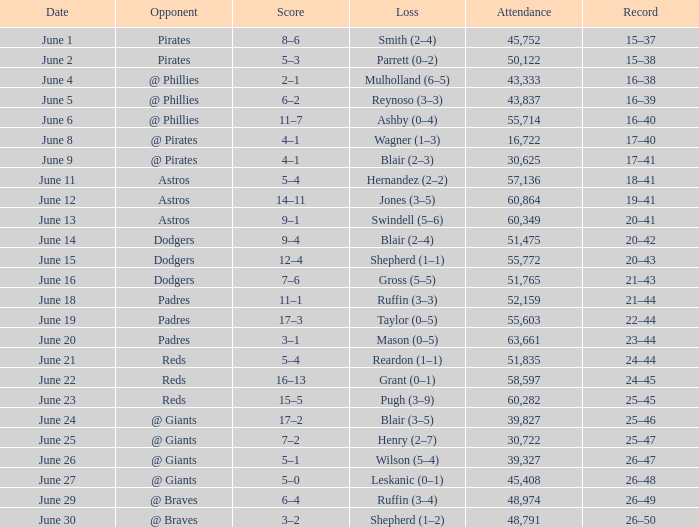What was the score on June 12? 14–11. 